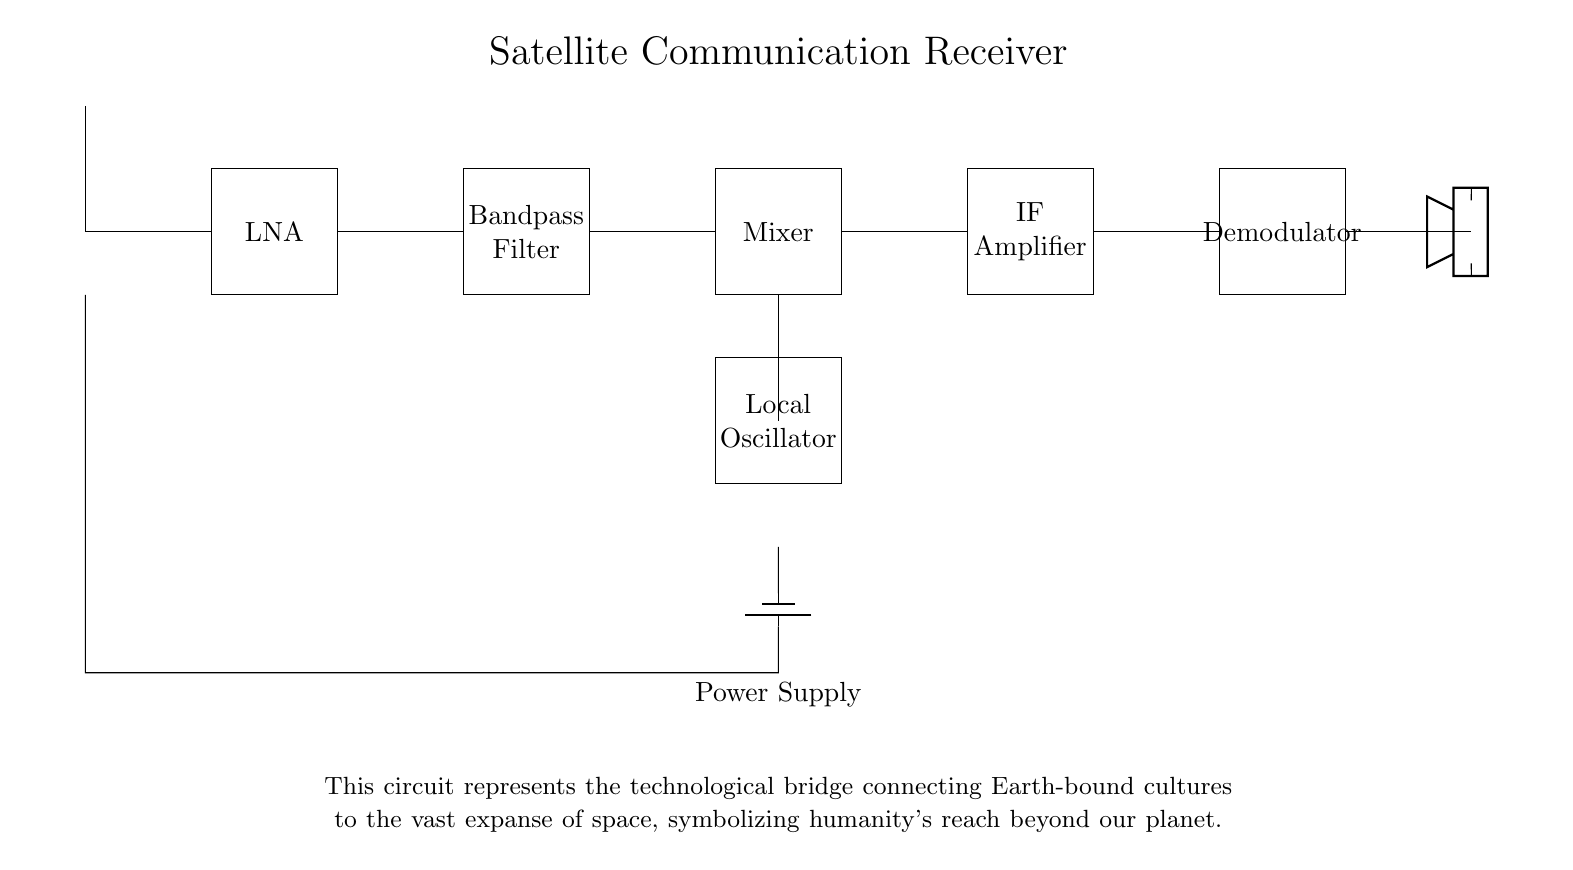What is the first component in the circuit? The first component is the antenna, which is designed to receive satellite signals. It is located at the top of the diagram.
Answer: antenna What is the function of the Local Oscillator? The Local Oscillator generates a frequency signal that mixes with the incoming signal in the Mixer to produce a lower intermediate frequency. This is essential for proper signal processing.
Answer: frequency generator How many amplification stages are in this circuit? There are two amplification stages in the circuit; the Low Noise Amplifier at the beginning and the IF Amplifier later in the setup.
Answer: two What does the Bandpass Filter do? The Bandpass Filter allows only a specific range of frequencies to pass while filtering out other frequencies, ensuring that the components downstream only process desired signals.
Answer: filters frequencies What is the output device in the circuit? The output device is the loudspeaker, which converts the demodulated audio signal into sound that we can hear, representing the final output of the receiver.
Answer: loudspeaker Why is the Power Supply crucial in this setup? The Power Supply is crucial as it provides the necessary electrical power for all components in the circuit to function. Without it, the circuit would not operate at all.
Answer: provides power 